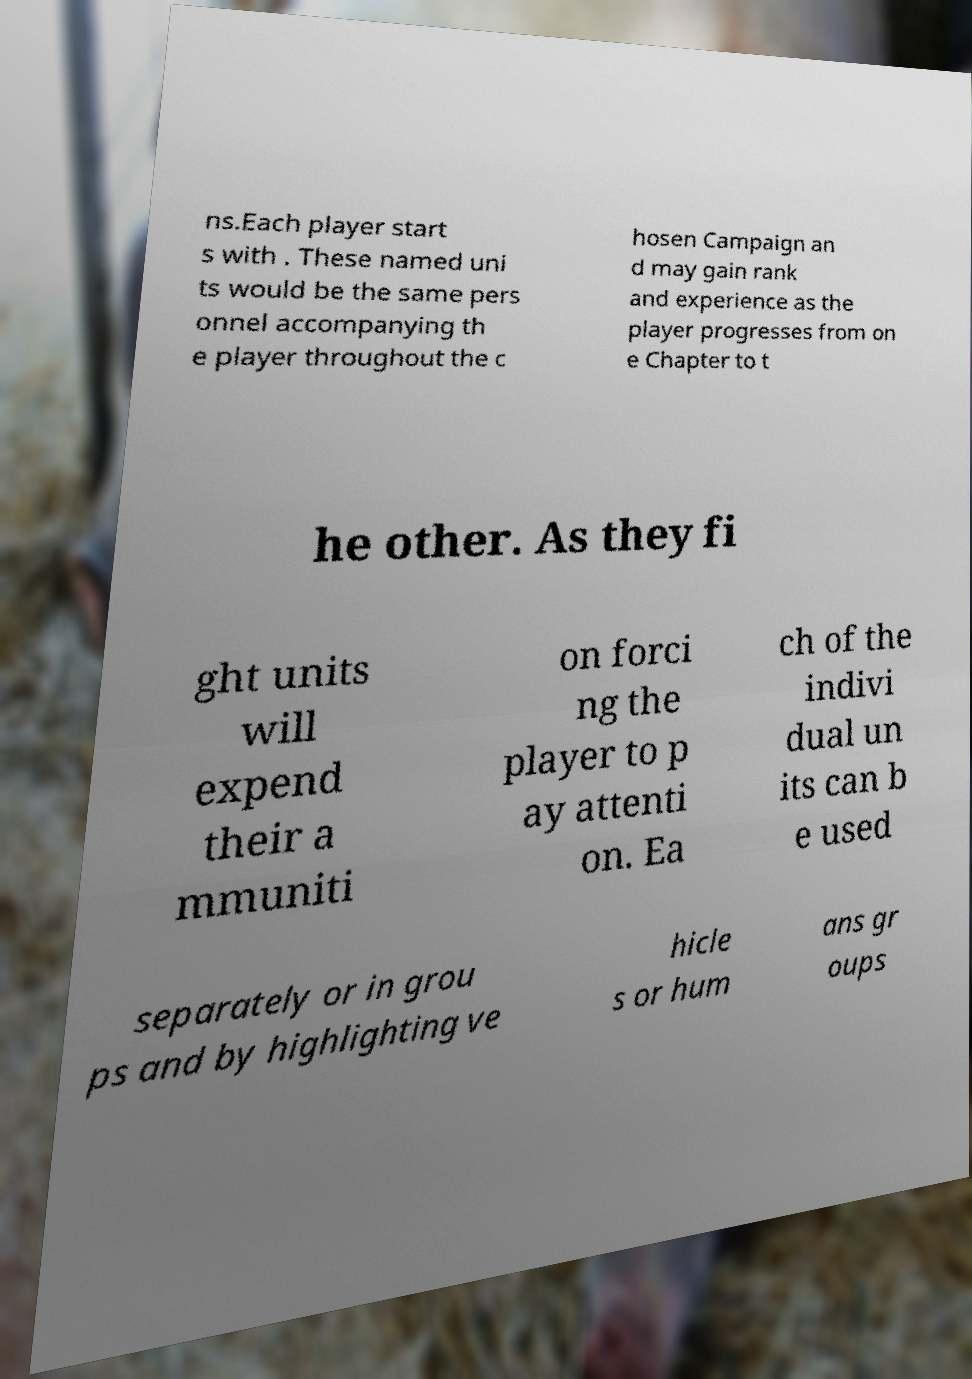Can you accurately transcribe the text from the provided image for me? ns.Each player start s with . These named uni ts would be the same pers onnel accompanying th e player throughout the c hosen Campaign an d may gain rank and experience as the player progresses from on e Chapter to t he other. As they fi ght units will expend their a mmuniti on forci ng the player to p ay attenti on. Ea ch of the indivi dual un its can b e used separately or in grou ps and by highlighting ve hicle s or hum ans gr oups 